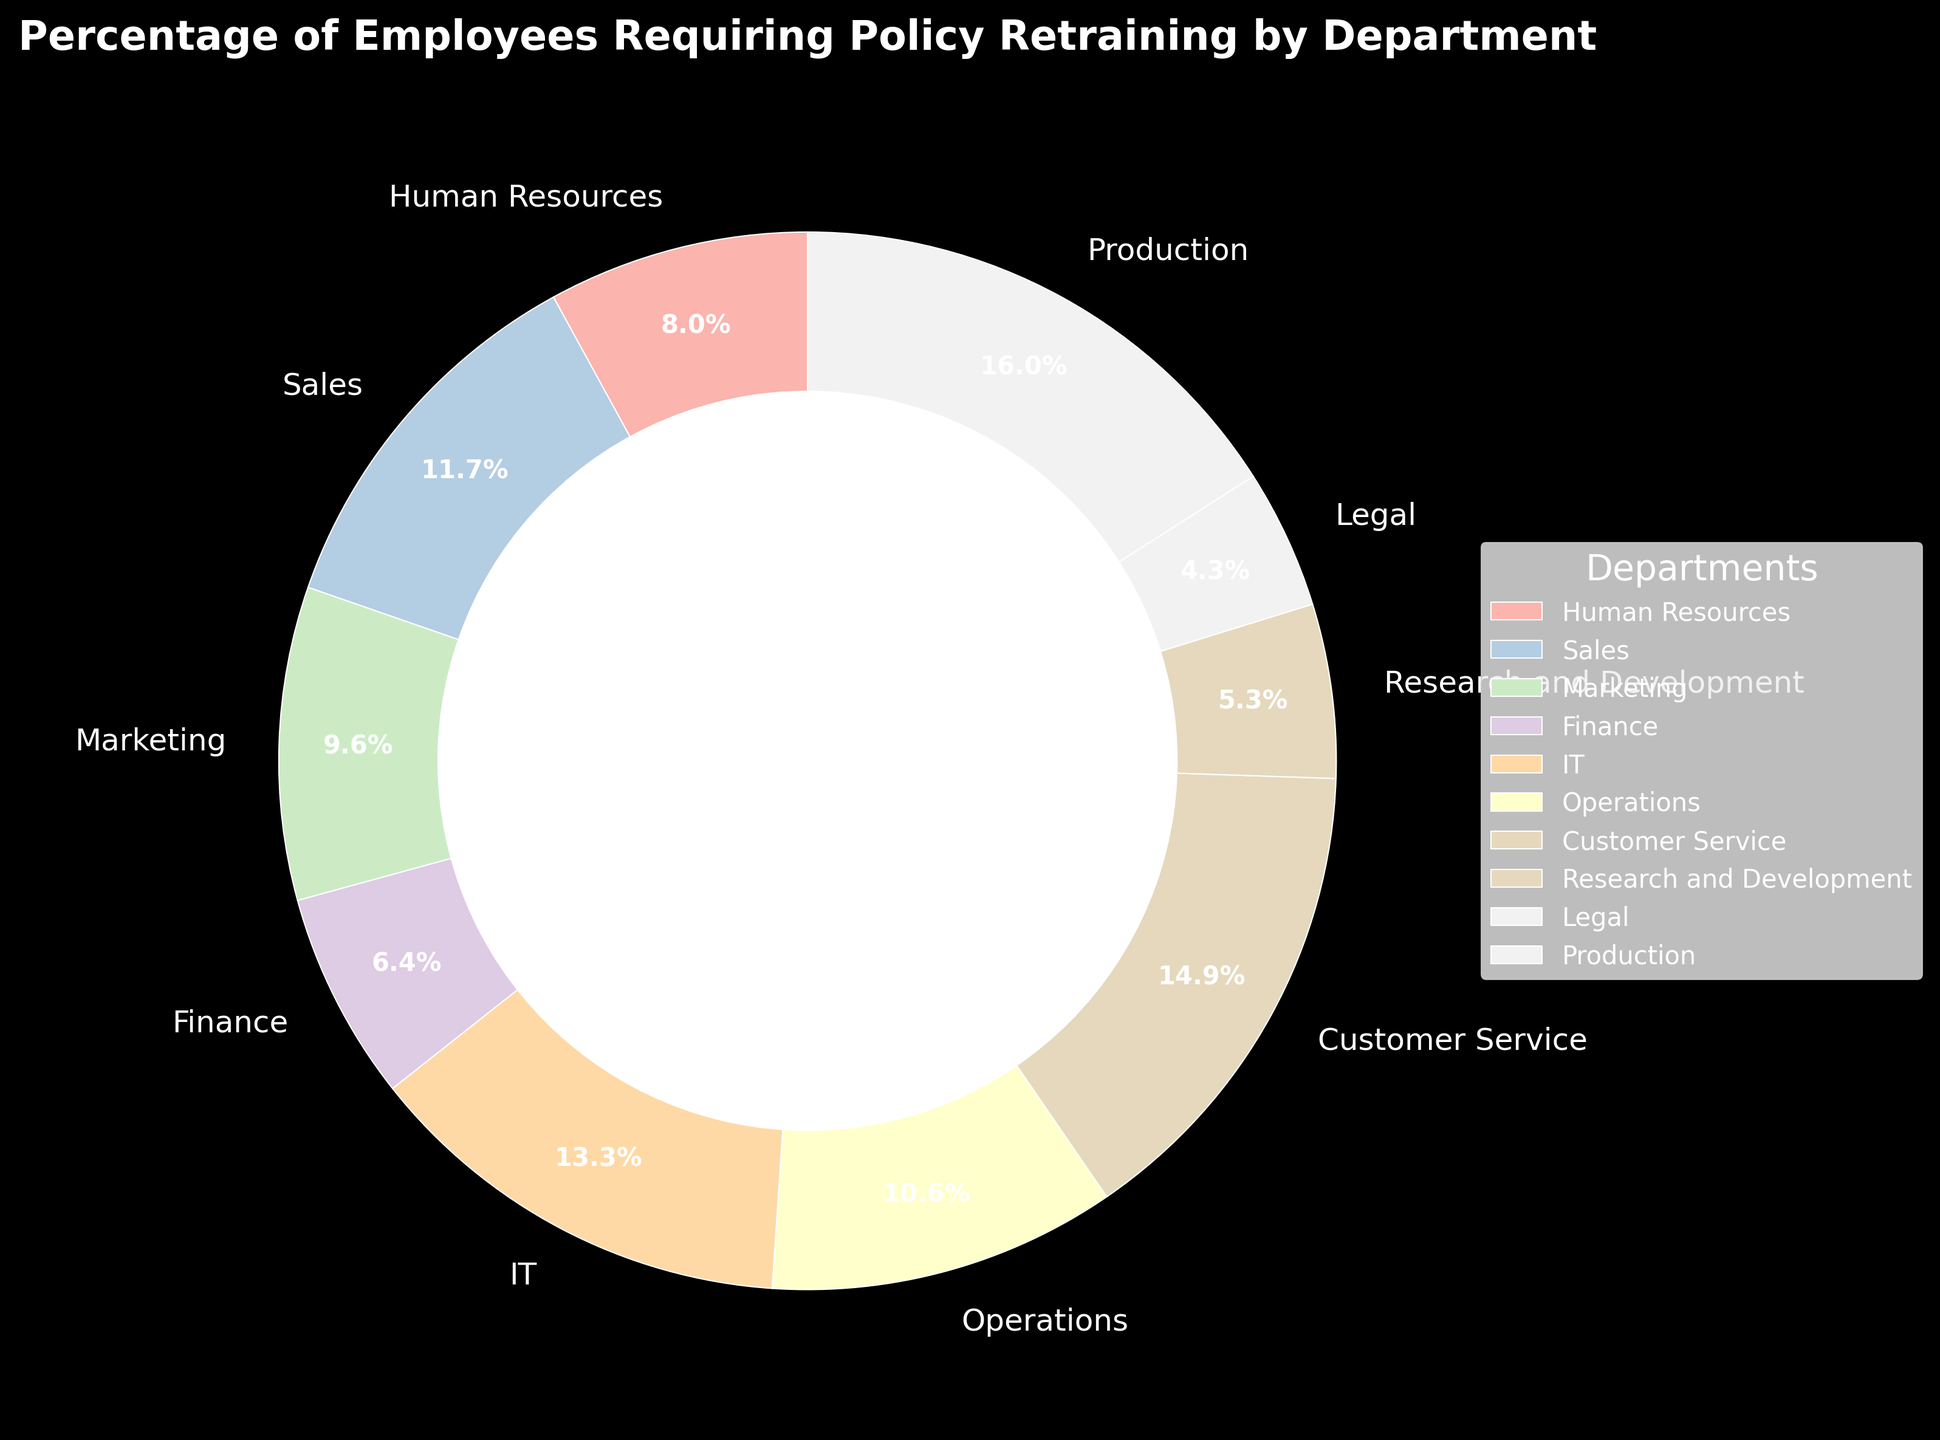Which department has the highest percentage of employees requiring policy retraining? First, locate the department with the largest pie slice. Compare the percentages to identify the highest percentage value. The department with the percentage of 30% is Production.
Answer: Production Which department has the lowest percentage of employees requiring policy retraining? Identify the smallest pie slice by percentage value. The smallest value given is 8%, which corresponds to the Legal department.
Answer: Legal What's the total percentage of employees requiring policy retraining in Sales and Marketing combined? Add the percentages of Sales and Marketing together. Sales has 22%, and Marketing has 18%. Therefore, the total is 22 + 18 = 40%.
Answer: 40% Which departments have a percentage of employees requiring policy retraining that is greater than 20%? Note the departments with values above the 20% threshold. Sales, IT, Customer Service, and Production all meet this criterion with 22%, 25%, 28%, and 30% respectively.
Answer: Sales, IT, Customer Service, Production What is the difference in the percentage of employees requiring policy retraining between Human Resources and Research and Development? Subtract the percentage of Research and Development from the percentage of Human Resources. Human Resources has 15% while Research and Development has 10%. Therefore, the difference is 15 - 10 = 5%.
Answer: 5% How many departments have a percentage of employees requiring policy retraining between 10% and 20% inclusive? Count the departments within the range of 10% to 20%, inclusive of boundary values. Human Resources (15%), Marketing (18%), Finance (12%), and Operations (20%) fit within this range, totaling four departments.
Answer: 4 What is the average percentage of employees requiring policy retraining across all departments? To find the average, sum all the department percentages and divide by the total number of departments. (15 + 22 + 18 + 12 + 25 + 20 + 28 + 10 + 8 + 30) / 10 = 188 / 10 = 18.8%.
Answer: 18.8% Which department requires retraining for exactly 1/5th or 20% of its employees? Locate the department with a 20% value. Operations has an exact 20% value.
Answer: Operations 